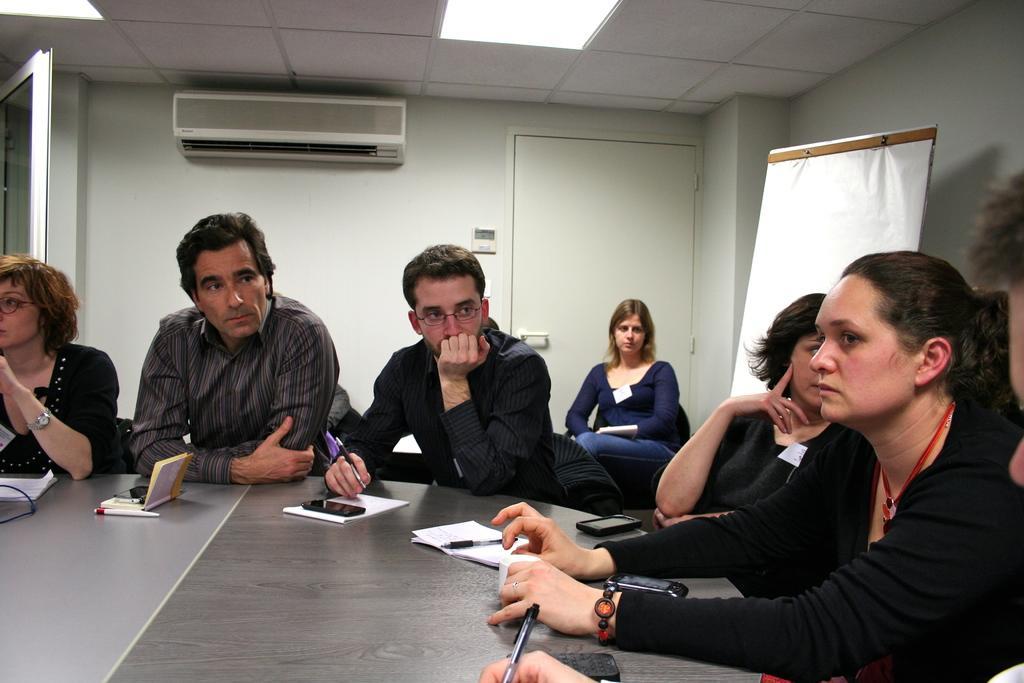Describe this image in one or two sentences. In this image we can see men and women are sitting. We can see a table at the bottom of the image. On the table, we can see penguins, book, mobiles, papers and wire. In the background, we can see a board, wall, AC, light, roof and door. 